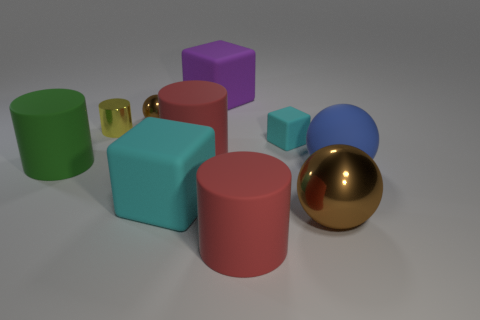Do the matte cylinder that is in front of the big blue rubber thing and the large matte cylinder behind the green matte object have the same color?
Your answer should be compact. Yes. There is a purple rubber thing; is it the same shape as the big red object that is on the left side of the large purple rubber object?
Give a very brief answer. No. What number of other objects are there of the same size as the blue matte sphere?
Ensure brevity in your answer.  6. What is the size of the shiny sphere in front of the green matte thing?
Ensure brevity in your answer.  Large. What is the shape of the big rubber thing that is the same color as the tiny rubber cube?
Your response must be concise. Cube. There is a blue thing; is its size the same as the brown sphere that is left of the large brown metallic object?
Make the answer very short. No. What is the size of the yellow object that is made of the same material as the large brown sphere?
Provide a succinct answer. Small. What number of big metal balls are left of the brown metallic thing that is behind the large metallic sphere?
Make the answer very short. 0. Is there another tiny thing that has the same shape as the purple thing?
Your response must be concise. Yes. What color is the big rubber thing behind the brown thing behind the yellow object?
Provide a short and direct response. Purple. 